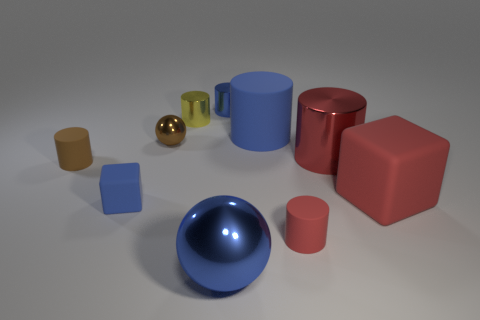Subtract all tiny yellow metal cylinders. How many cylinders are left? 5 Subtract all yellow cylinders. How many cylinders are left? 5 Subtract all purple cylinders. Subtract all purple cubes. How many cylinders are left? 6 Subtract all balls. How many objects are left? 8 Add 4 purple rubber cubes. How many purple rubber cubes exist? 4 Subtract 0 green cubes. How many objects are left? 10 Subtract all big brown matte things. Subtract all tiny rubber things. How many objects are left? 7 Add 7 tiny brown cylinders. How many tiny brown cylinders are left? 8 